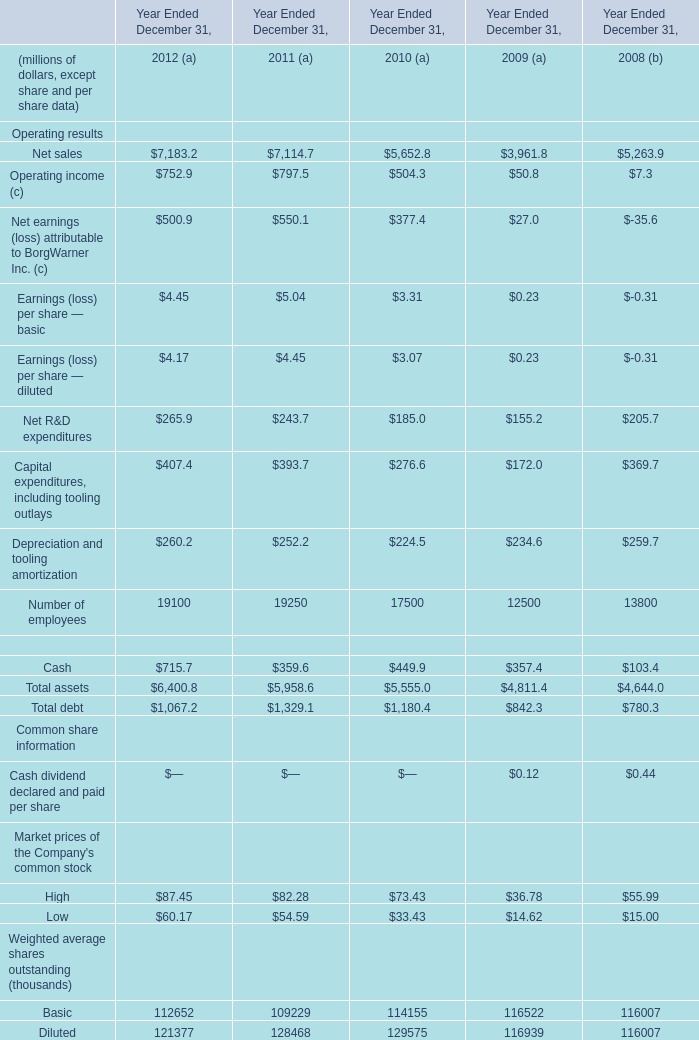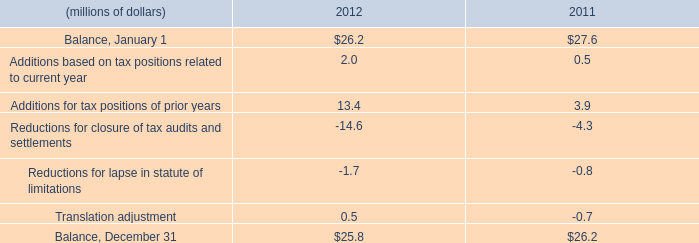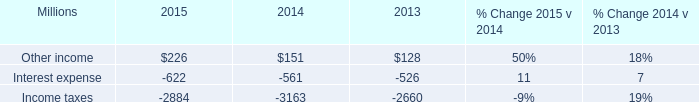In which years is cash greater than operating income? 
Answer: 2008 and 2009. 